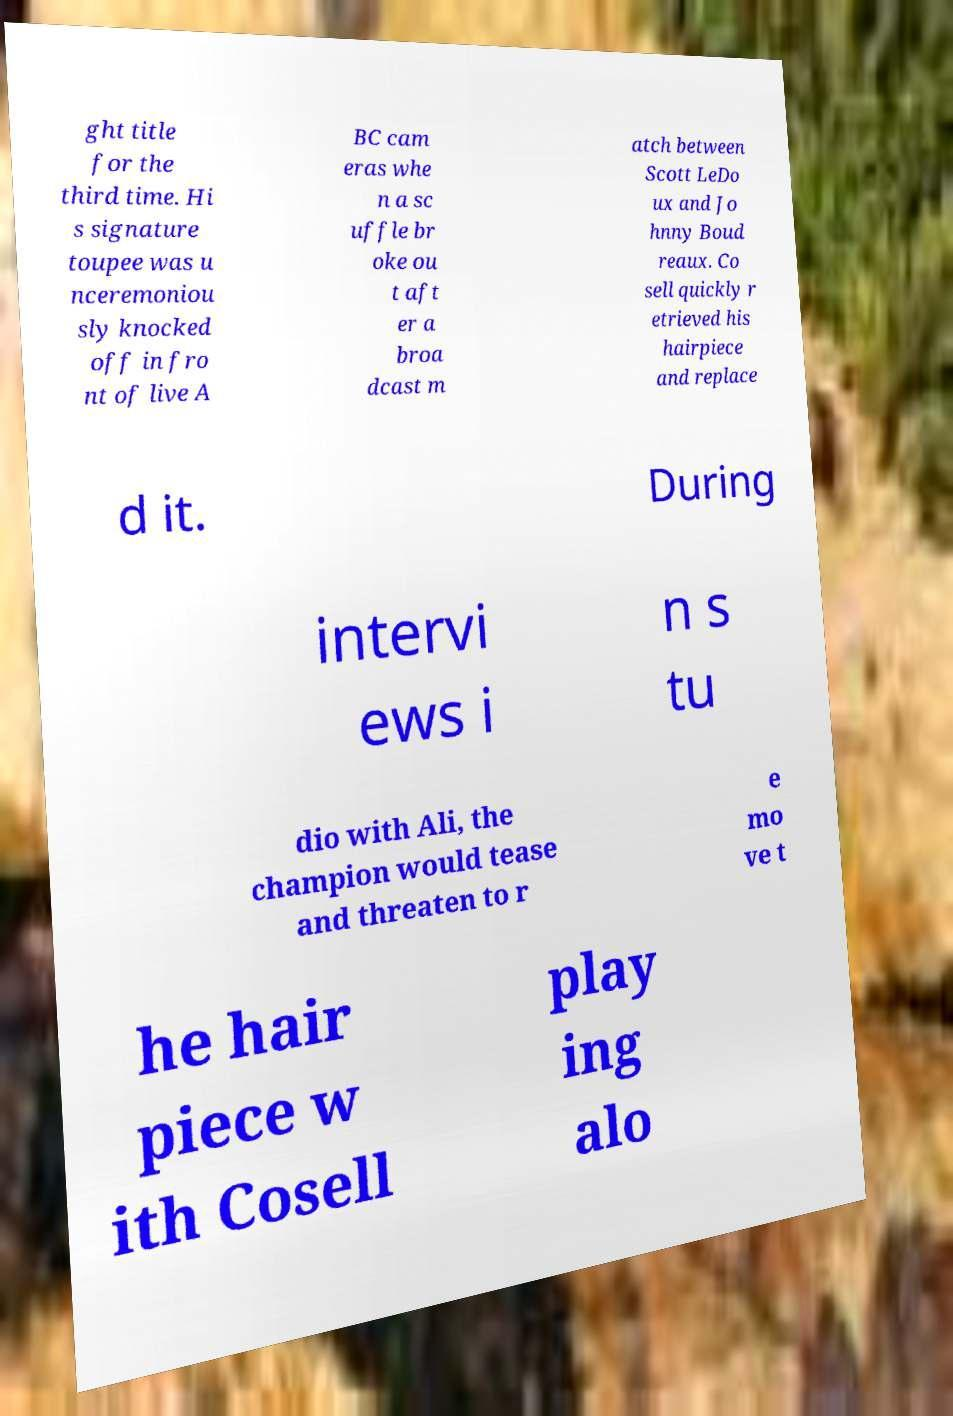There's text embedded in this image that I need extracted. Can you transcribe it verbatim? ght title for the third time. Hi s signature toupee was u nceremoniou sly knocked off in fro nt of live A BC cam eras whe n a sc uffle br oke ou t aft er a broa dcast m atch between Scott LeDo ux and Jo hnny Boud reaux. Co sell quickly r etrieved his hairpiece and replace d it. During intervi ews i n s tu dio with Ali, the champion would tease and threaten to r e mo ve t he hair piece w ith Cosell play ing alo 